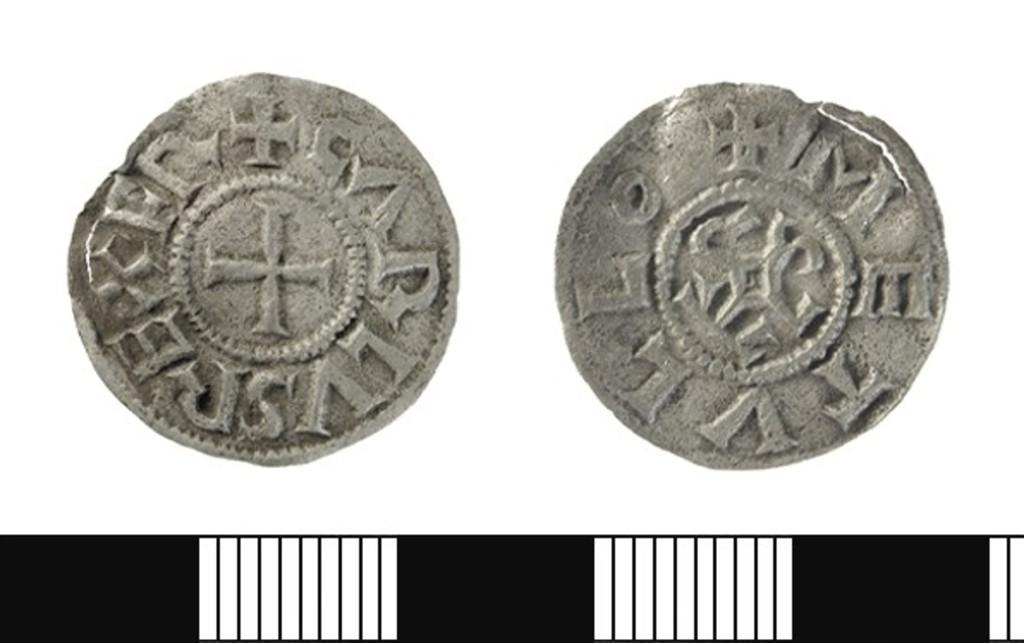Are the letters engraved english?
Offer a very short reply. No. 